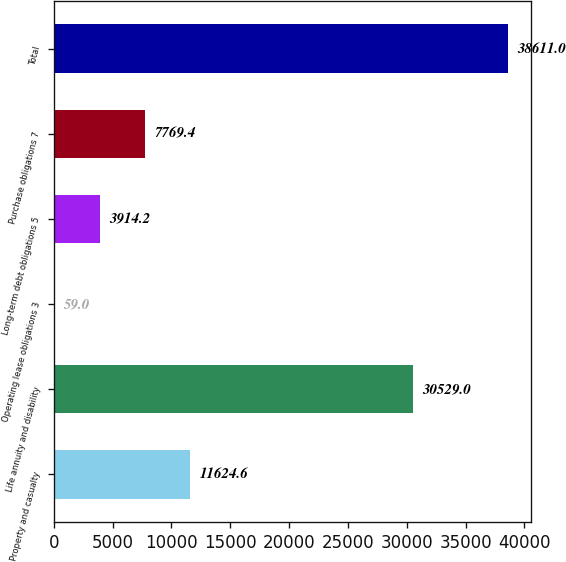Convert chart. <chart><loc_0><loc_0><loc_500><loc_500><bar_chart><fcel>Property and casualty<fcel>Life annuity and disability<fcel>Operating lease obligations 3<fcel>Long-term debt obligations 5<fcel>Purchase obligations 7<fcel>Total<nl><fcel>11624.6<fcel>30529<fcel>59<fcel>3914.2<fcel>7769.4<fcel>38611<nl></chart> 